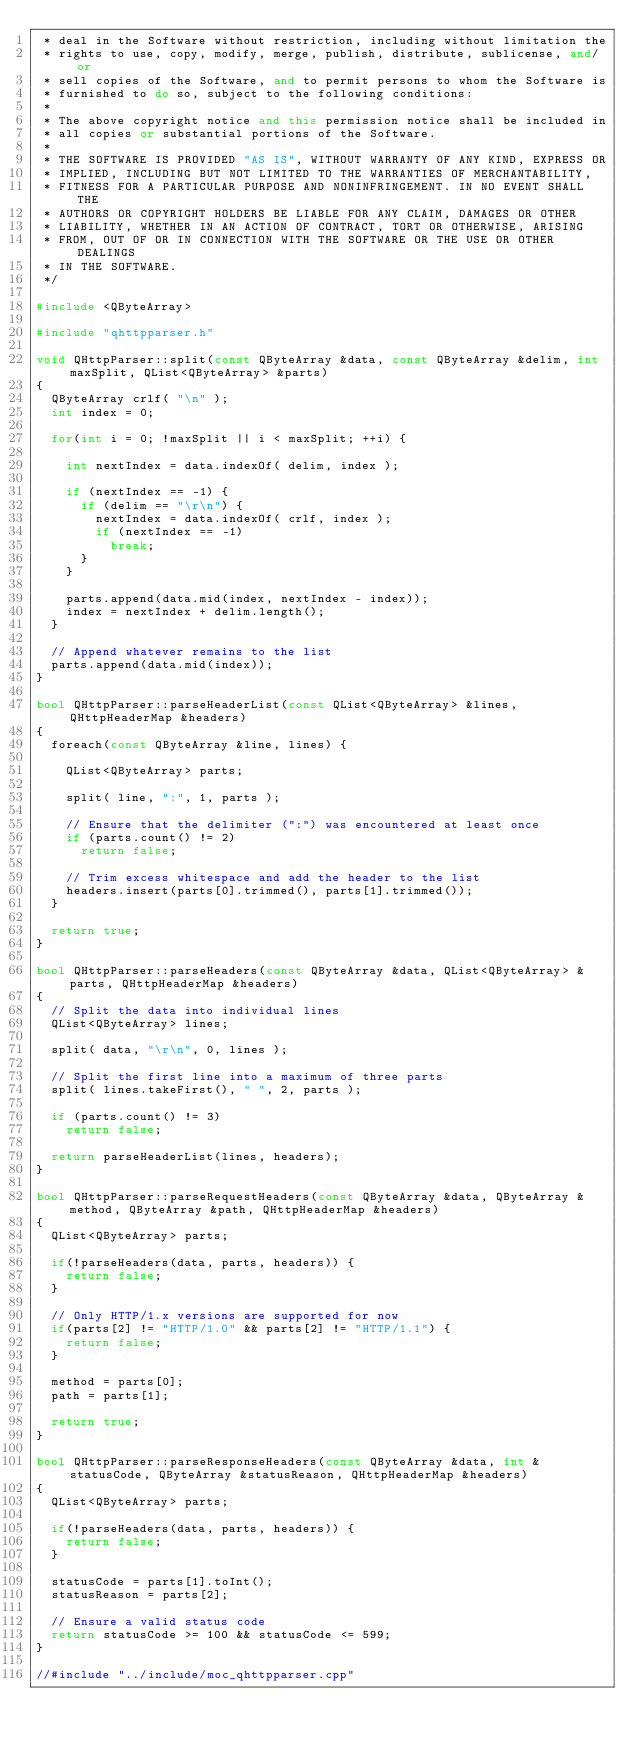<code> <loc_0><loc_0><loc_500><loc_500><_C++_> * deal in the Software without restriction, including without limitation the
 * rights to use, copy, modify, merge, publish, distribute, sublicense, and/or
 * sell copies of the Software, and to permit persons to whom the Software is
 * furnished to do so, subject to the following conditions:
 *
 * The above copyright notice and this permission notice shall be included in
 * all copies or substantial portions of the Software.
 *
 * THE SOFTWARE IS PROVIDED "AS IS", WITHOUT WARRANTY OF ANY KIND, EXPRESS OR
 * IMPLIED, INCLUDING BUT NOT LIMITED TO THE WARRANTIES OF MERCHANTABILITY,
 * FITNESS FOR A PARTICULAR PURPOSE AND NONINFRINGEMENT. IN NO EVENT SHALL THE
 * AUTHORS OR COPYRIGHT HOLDERS BE LIABLE FOR ANY CLAIM, DAMAGES OR OTHER
 * LIABILITY, WHETHER IN AN ACTION OF CONTRACT, TORT OR OTHERWISE, ARISING
 * FROM, OUT OF OR IN CONNECTION WITH THE SOFTWARE OR THE USE OR OTHER DEALINGS
 * IN THE SOFTWARE.
 */

#include <QByteArray>

#include "qhttpparser.h"

void QHttpParser::split(const QByteArray &data, const QByteArray &delim, int maxSplit, QList<QByteArray> &parts)
{
	QByteArray crlf( "\n" );
	int index = 0;

	for(int i = 0; !maxSplit || i < maxSplit; ++i) {

		int nextIndex = data.indexOf( delim, index );

		if (nextIndex == -1) {
			if (delim == "\r\n") {
				nextIndex = data.indexOf( crlf, index );
				if (nextIndex == -1)
					break;
			}
		}

		parts.append(data.mid(index, nextIndex - index));
		index = nextIndex + delim.length();
	}

	// Append whatever remains to the list
	parts.append(data.mid(index));
}

bool QHttpParser::parseHeaderList(const QList<QByteArray> &lines, QHttpHeaderMap &headers)
{
	foreach(const QByteArray &line, lines) {

		QList<QByteArray> parts;

		split( line, ":", 1, parts );

		// Ensure that the delimiter (":") was encountered at least once
		if (parts.count() != 2)
			return false;

		// Trim excess whitespace and add the header to the list
		headers.insert(parts[0].trimmed(), parts[1].trimmed());
	}

	return true;
}

bool QHttpParser::parseHeaders(const QByteArray &data, QList<QByteArray> &parts, QHttpHeaderMap &headers)
{
	// Split the data into individual lines
	QList<QByteArray> lines;

	split( data, "\r\n", 0, lines );

	// Split the first line into a maximum of three parts
	split( lines.takeFirst(), " ", 2, parts );

	if (parts.count() != 3)
		return false;

	return parseHeaderList(lines, headers);
}

bool QHttpParser::parseRequestHeaders(const QByteArray &data, QByteArray &method, QByteArray &path, QHttpHeaderMap &headers)
{
	QList<QByteArray> parts;

	if(!parseHeaders(data, parts, headers)) {
		return false;
	}

	// Only HTTP/1.x versions are supported for now
	if(parts[2] != "HTTP/1.0" && parts[2] != "HTTP/1.1") {
		return false;
	}

	method = parts[0];
	path = parts[1];

	return true;
}

bool QHttpParser::parseResponseHeaders(const QByteArray &data, int &statusCode, QByteArray &statusReason, QHttpHeaderMap &headers)
{
	QList<QByteArray> parts;

	if(!parseHeaders(data, parts, headers)) {
		return false;
	}

	statusCode = parts[1].toInt();
	statusReason = parts[2];

	// Ensure a valid status code
	return statusCode >= 100 && statusCode <= 599;
}

//#include "../include/moc_qhttpparser.cpp"

</code> 